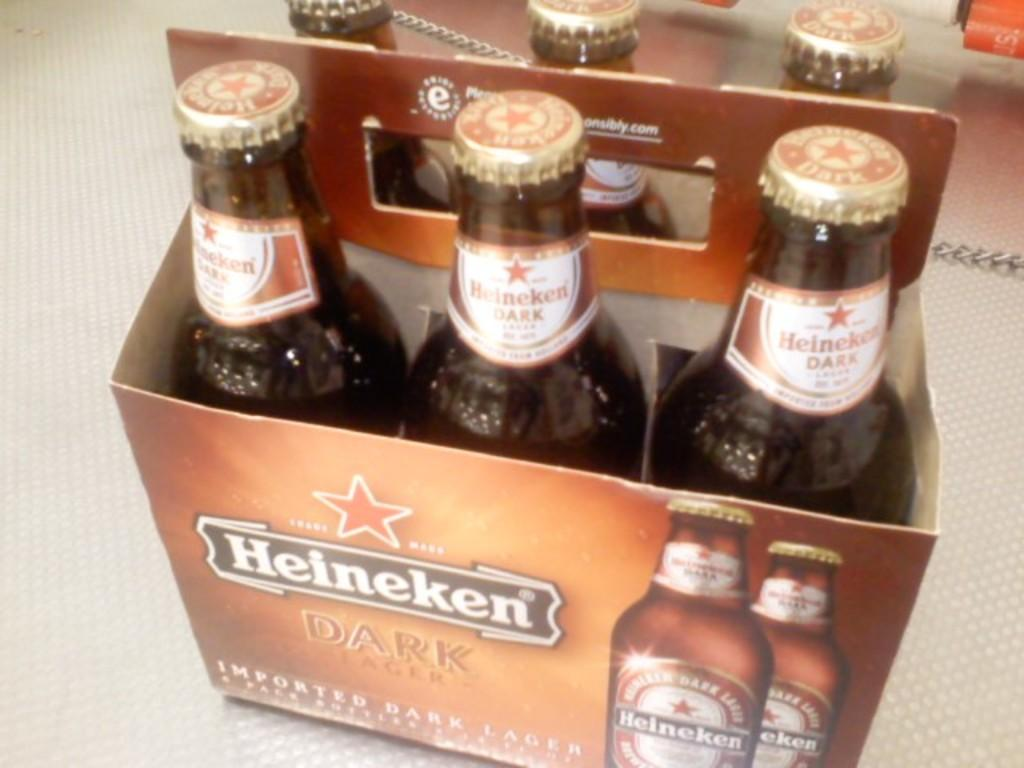<image>
Give a short and clear explanation of the subsequent image. A sixpack on Heinken Dark Lager sits on a counter. 